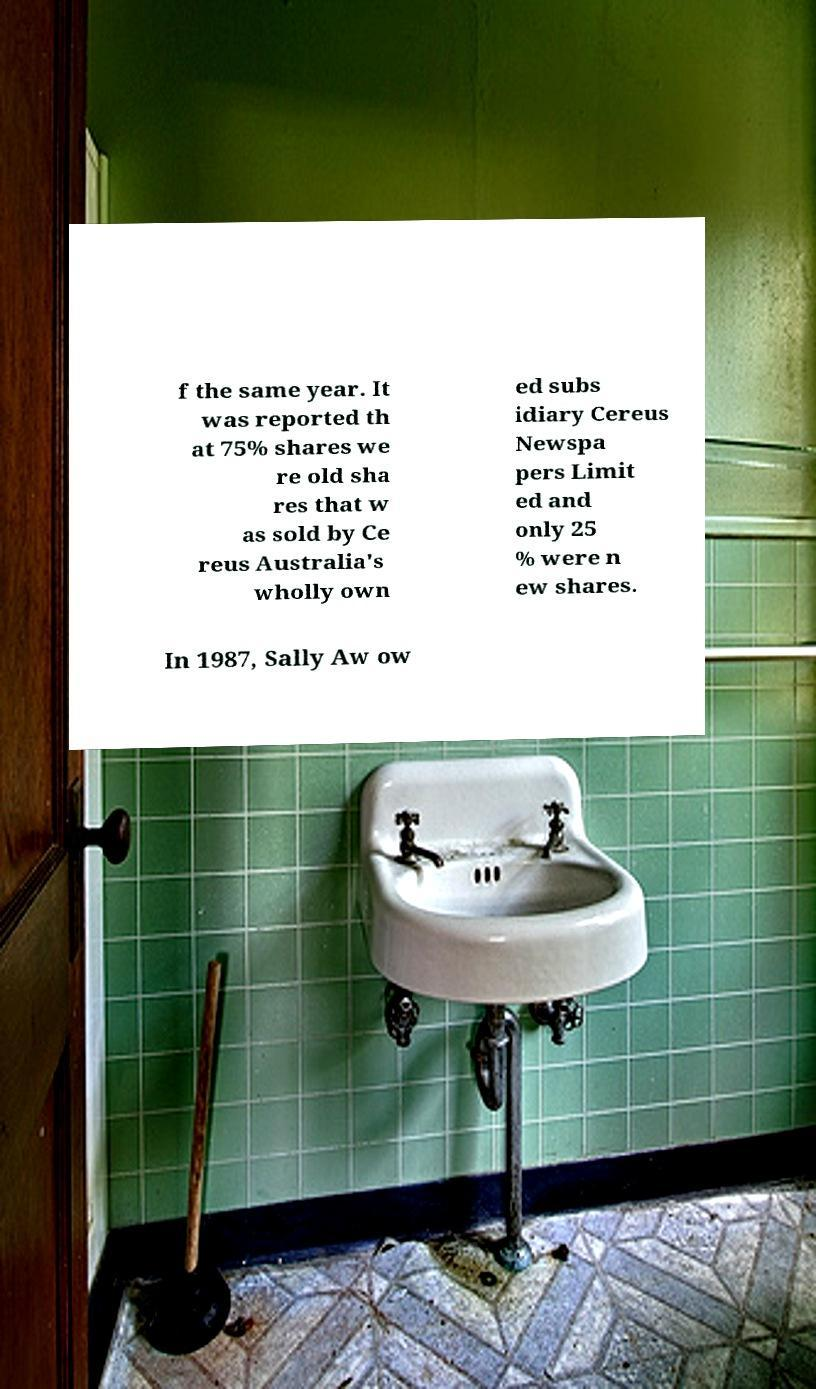I need the written content from this picture converted into text. Can you do that? f the same year. It was reported th at 75% shares we re old sha res that w as sold by Ce reus Australia's wholly own ed subs idiary Cereus Newspa pers Limit ed and only 25 % were n ew shares. In 1987, Sally Aw ow 